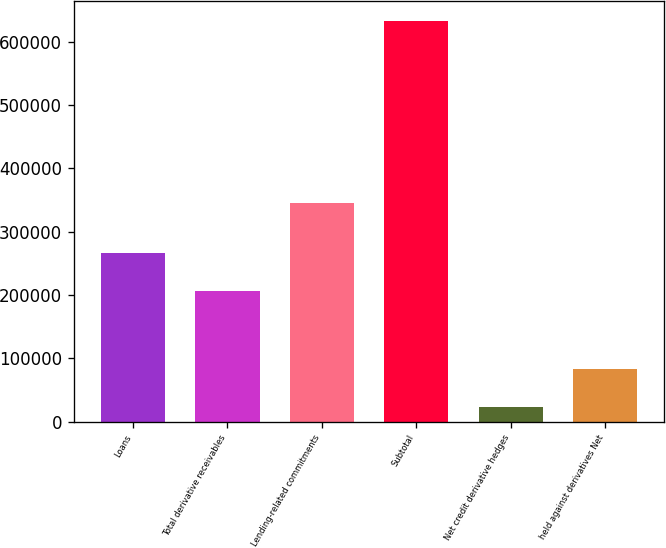Convert chart to OTSL. <chart><loc_0><loc_0><loc_500><loc_500><bar_chart><fcel>Loans<fcel>Total derivative receivables<fcel>Lending-related commitments<fcel>Subtotal<fcel>Net credit derivative hedges<fcel>held against derivatives Net<nl><fcel>266898<fcel>205951<fcel>346079<fcel>632584<fcel>23108<fcel>84055.6<nl></chart> 